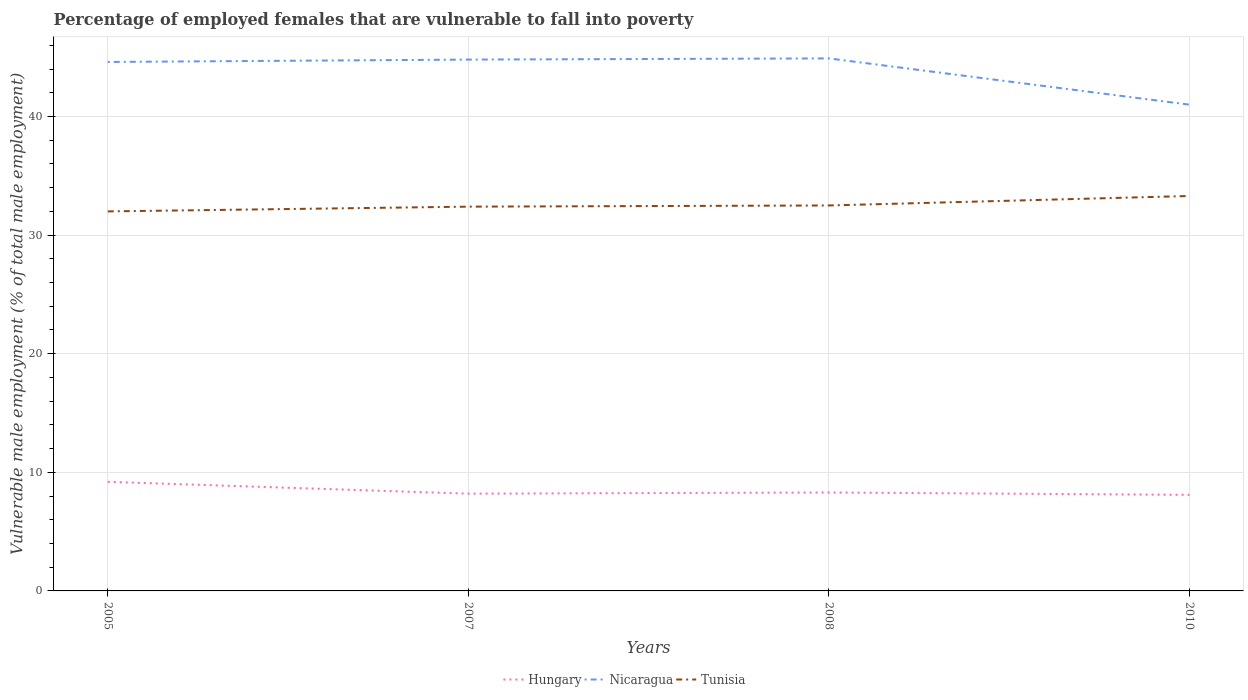Does the line corresponding to Tunisia intersect with the line corresponding to Hungary?
Ensure brevity in your answer.  No. Is the number of lines equal to the number of legend labels?
Provide a succinct answer. Yes. In which year was the percentage of employed females who are vulnerable to fall into poverty in Hungary maximum?
Your answer should be compact. 2010. What is the total percentage of employed females who are vulnerable to fall into poverty in Tunisia in the graph?
Give a very brief answer. -0.8. What is the difference between the highest and the second highest percentage of employed females who are vulnerable to fall into poverty in Nicaragua?
Keep it short and to the point. 3.9. What is the difference between the highest and the lowest percentage of employed females who are vulnerable to fall into poverty in Hungary?
Keep it short and to the point. 1. How many years are there in the graph?
Ensure brevity in your answer.  4. Are the values on the major ticks of Y-axis written in scientific E-notation?
Keep it short and to the point. No. Does the graph contain any zero values?
Your response must be concise. No. How many legend labels are there?
Your response must be concise. 3. What is the title of the graph?
Your response must be concise. Percentage of employed females that are vulnerable to fall into poverty. What is the label or title of the Y-axis?
Your answer should be compact. Vulnerable male employment (% of total male employment). What is the Vulnerable male employment (% of total male employment) of Hungary in 2005?
Give a very brief answer. 9.2. What is the Vulnerable male employment (% of total male employment) in Nicaragua in 2005?
Make the answer very short. 44.6. What is the Vulnerable male employment (% of total male employment) in Tunisia in 2005?
Ensure brevity in your answer.  32. What is the Vulnerable male employment (% of total male employment) in Hungary in 2007?
Ensure brevity in your answer.  8.2. What is the Vulnerable male employment (% of total male employment) in Nicaragua in 2007?
Offer a very short reply. 44.8. What is the Vulnerable male employment (% of total male employment) of Tunisia in 2007?
Your response must be concise. 32.4. What is the Vulnerable male employment (% of total male employment) of Hungary in 2008?
Provide a succinct answer. 8.3. What is the Vulnerable male employment (% of total male employment) in Nicaragua in 2008?
Give a very brief answer. 44.9. What is the Vulnerable male employment (% of total male employment) of Tunisia in 2008?
Offer a terse response. 32.5. What is the Vulnerable male employment (% of total male employment) of Hungary in 2010?
Ensure brevity in your answer.  8.1. What is the Vulnerable male employment (% of total male employment) in Tunisia in 2010?
Offer a terse response. 33.3. Across all years, what is the maximum Vulnerable male employment (% of total male employment) in Hungary?
Give a very brief answer. 9.2. Across all years, what is the maximum Vulnerable male employment (% of total male employment) of Nicaragua?
Provide a short and direct response. 44.9. Across all years, what is the maximum Vulnerable male employment (% of total male employment) in Tunisia?
Offer a terse response. 33.3. Across all years, what is the minimum Vulnerable male employment (% of total male employment) of Hungary?
Provide a short and direct response. 8.1. What is the total Vulnerable male employment (% of total male employment) of Hungary in the graph?
Provide a succinct answer. 33.8. What is the total Vulnerable male employment (% of total male employment) of Nicaragua in the graph?
Make the answer very short. 175.3. What is the total Vulnerable male employment (% of total male employment) in Tunisia in the graph?
Your answer should be compact. 130.2. What is the difference between the Vulnerable male employment (% of total male employment) in Hungary in 2005 and that in 2008?
Provide a succinct answer. 0.9. What is the difference between the Vulnerable male employment (% of total male employment) in Tunisia in 2005 and that in 2008?
Keep it short and to the point. -0.5. What is the difference between the Vulnerable male employment (% of total male employment) in Hungary in 2005 and that in 2010?
Offer a terse response. 1.1. What is the difference between the Vulnerable male employment (% of total male employment) of Nicaragua in 2005 and that in 2010?
Offer a terse response. 3.6. What is the difference between the Vulnerable male employment (% of total male employment) of Tunisia in 2005 and that in 2010?
Provide a succinct answer. -1.3. What is the difference between the Vulnerable male employment (% of total male employment) in Nicaragua in 2007 and that in 2008?
Keep it short and to the point. -0.1. What is the difference between the Vulnerable male employment (% of total male employment) in Hungary in 2007 and that in 2010?
Offer a terse response. 0.1. What is the difference between the Vulnerable male employment (% of total male employment) in Nicaragua in 2007 and that in 2010?
Ensure brevity in your answer.  3.8. What is the difference between the Vulnerable male employment (% of total male employment) of Nicaragua in 2008 and that in 2010?
Ensure brevity in your answer.  3.9. What is the difference between the Vulnerable male employment (% of total male employment) in Hungary in 2005 and the Vulnerable male employment (% of total male employment) in Nicaragua in 2007?
Your answer should be very brief. -35.6. What is the difference between the Vulnerable male employment (% of total male employment) of Hungary in 2005 and the Vulnerable male employment (% of total male employment) of Tunisia in 2007?
Offer a terse response. -23.2. What is the difference between the Vulnerable male employment (% of total male employment) in Hungary in 2005 and the Vulnerable male employment (% of total male employment) in Nicaragua in 2008?
Give a very brief answer. -35.7. What is the difference between the Vulnerable male employment (% of total male employment) of Hungary in 2005 and the Vulnerable male employment (% of total male employment) of Tunisia in 2008?
Your answer should be compact. -23.3. What is the difference between the Vulnerable male employment (% of total male employment) in Hungary in 2005 and the Vulnerable male employment (% of total male employment) in Nicaragua in 2010?
Make the answer very short. -31.8. What is the difference between the Vulnerable male employment (% of total male employment) of Hungary in 2005 and the Vulnerable male employment (% of total male employment) of Tunisia in 2010?
Offer a terse response. -24.1. What is the difference between the Vulnerable male employment (% of total male employment) in Hungary in 2007 and the Vulnerable male employment (% of total male employment) in Nicaragua in 2008?
Offer a terse response. -36.7. What is the difference between the Vulnerable male employment (% of total male employment) in Hungary in 2007 and the Vulnerable male employment (% of total male employment) in Tunisia in 2008?
Keep it short and to the point. -24.3. What is the difference between the Vulnerable male employment (% of total male employment) of Nicaragua in 2007 and the Vulnerable male employment (% of total male employment) of Tunisia in 2008?
Give a very brief answer. 12.3. What is the difference between the Vulnerable male employment (% of total male employment) of Hungary in 2007 and the Vulnerable male employment (% of total male employment) of Nicaragua in 2010?
Keep it short and to the point. -32.8. What is the difference between the Vulnerable male employment (% of total male employment) in Hungary in 2007 and the Vulnerable male employment (% of total male employment) in Tunisia in 2010?
Your answer should be compact. -25.1. What is the difference between the Vulnerable male employment (% of total male employment) of Nicaragua in 2007 and the Vulnerable male employment (% of total male employment) of Tunisia in 2010?
Make the answer very short. 11.5. What is the difference between the Vulnerable male employment (% of total male employment) of Hungary in 2008 and the Vulnerable male employment (% of total male employment) of Nicaragua in 2010?
Your answer should be compact. -32.7. What is the difference between the Vulnerable male employment (% of total male employment) in Hungary in 2008 and the Vulnerable male employment (% of total male employment) in Tunisia in 2010?
Your response must be concise. -25. What is the difference between the Vulnerable male employment (% of total male employment) of Nicaragua in 2008 and the Vulnerable male employment (% of total male employment) of Tunisia in 2010?
Provide a succinct answer. 11.6. What is the average Vulnerable male employment (% of total male employment) in Hungary per year?
Offer a very short reply. 8.45. What is the average Vulnerable male employment (% of total male employment) in Nicaragua per year?
Your response must be concise. 43.83. What is the average Vulnerable male employment (% of total male employment) in Tunisia per year?
Ensure brevity in your answer.  32.55. In the year 2005, what is the difference between the Vulnerable male employment (% of total male employment) in Hungary and Vulnerable male employment (% of total male employment) in Nicaragua?
Ensure brevity in your answer.  -35.4. In the year 2005, what is the difference between the Vulnerable male employment (% of total male employment) in Hungary and Vulnerable male employment (% of total male employment) in Tunisia?
Offer a very short reply. -22.8. In the year 2007, what is the difference between the Vulnerable male employment (% of total male employment) of Hungary and Vulnerable male employment (% of total male employment) of Nicaragua?
Your answer should be very brief. -36.6. In the year 2007, what is the difference between the Vulnerable male employment (% of total male employment) in Hungary and Vulnerable male employment (% of total male employment) in Tunisia?
Your answer should be very brief. -24.2. In the year 2007, what is the difference between the Vulnerable male employment (% of total male employment) in Nicaragua and Vulnerable male employment (% of total male employment) in Tunisia?
Offer a very short reply. 12.4. In the year 2008, what is the difference between the Vulnerable male employment (% of total male employment) of Hungary and Vulnerable male employment (% of total male employment) of Nicaragua?
Your answer should be compact. -36.6. In the year 2008, what is the difference between the Vulnerable male employment (% of total male employment) of Hungary and Vulnerable male employment (% of total male employment) of Tunisia?
Offer a terse response. -24.2. In the year 2008, what is the difference between the Vulnerable male employment (% of total male employment) of Nicaragua and Vulnerable male employment (% of total male employment) of Tunisia?
Offer a terse response. 12.4. In the year 2010, what is the difference between the Vulnerable male employment (% of total male employment) of Hungary and Vulnerable male employment (% of total male employment) of Nicaragua?
Your answer should be compact. -32.9. In the year 2010, what is the difference between the Vulnerable male employment (% of total male employment) of Hungary and Vulnerable male employment (% of total male employment) of Tunisia?
Ensure brevity in your answer.  -25.2. What is the ratio of the Vulnerable male employment (% of total male employment) of Hungary in 2005 to that in 2007?
Offer a terse response. 1.12. What is the ratio of the Vulnerable male employment (% of total male employment) of Nicaragua in 2005 to that in 2007?
Give a very brief answer. 1. What is the ratio of the Vulnerable male employment (% of total male employment) in Hungary in 2005 to that in 2008?
Your response must be concise. 1.11. What is the ratio of the Vulnerable male employment (% of total male employment) in Tunisia in 2005 to that in 2008?
Give a very brief answer. 0.98. What is the ratio of the Vulnerable male employment (% of total male employment) of Hungary in 2005 to that in 2010?
Your answer should be very brief. 1.14. What is the ratio of the Vulnerable male employment (% of total male employment) of Nicaragua in 2005 to that in 2010?
Your answer should be very brief. 1.09. What is the ratio of the Vulnerable male employment (% of total male employment) of Tunisia in 2005 to that in 2010?
Your response must be concise. 0.96. What is the ratio of the Vulnerable male employment (% of total male employment) of Nicaragua in 2007 to that in 2008?
Your answer should be very brief. 1. What is the ratio of the Vulnerable male employment (% of total male employment) in Tunisia in 2007 to that in 2008?
Provide a succinct answer. 1. What is the ratio of the Vulnerable male employment (% of total male employment) of Hungary in 2007 to that in 2010?
Your answer should be compact. 1.01. What is the ratio of the Vulnerable male employment (% of total male employment) in Nicaragua in 2007 to that in 2010?
Your answer should be very brief. 1.09. What is the ratio of the Vulnerable male employment (% of total male employment) in Tunisia in 2007 to that in 2010?
Keep it short and to the point. 0.97. What is the ratio of the Vulnerable male employment (% of total male employment) in Hungary in 2008 to that in 2010?
Your response must be concise. 1.02. What is the ratio of the Vulnerable male employment (% of total male employment) of Nicaragua in 2008 to that in 2010?
Offer a very short reply. 1.1. What is the ratio of the Vulnerable male employment (% of total male employment) of Tunisia in 2008 to that in 2010?
Give a very brief answer. 0.98. What is the difference between the highest and the second highest Vulnerable male employment (% of total male employment) of Tunisia?
Your response must be concise. 0.8. 